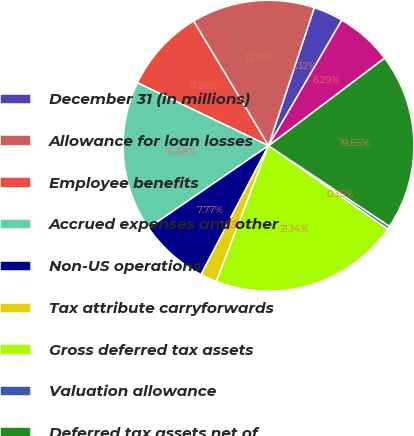Convert chart. <chart><loc_0><loc_0><loc_500><loc_500><pie_chart><fcel>December 31 (in millions)<fcel>Allowance for loan losses<fcel>Employee benefits<fcel>Accrued expenses and other<fcel>Non-US operations<fcel>Tax attribute carryforwards<fcel>Gross deferred tax assets<fcel>Valuation allowance<fcel>Deferred tax assets net of<fcel>Depreciation and amortization<nl><fcel>3.32%<fcel>13.71%<fcel>9.26%<fcel>16.68%<fcel>7.77%<fcel>1.83%<fcel>21.14%<fcel>0.35%<fcel>19.65%<fcel>6.29%<nl></chart> 